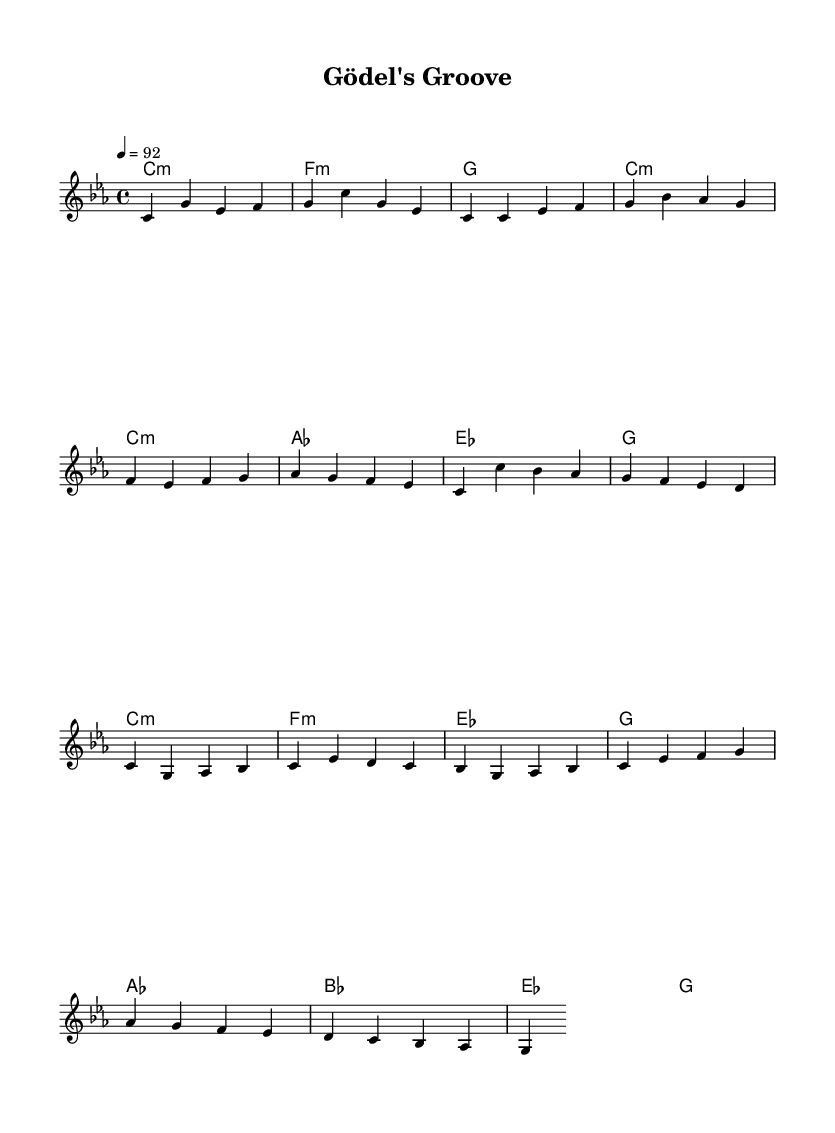What is the key signature of this music? The key signature is C minor, which has three flats (B flat, E flat, and A flat). This can be determined by looking at the key signature section at the beginning of the sheet music where the C minor indication is noted.
Answer: C minor What is the time signature used in the piece? The time signature is 4/4, which indicates four beats per measure. This can be confirmed by looking at the time signature at the beginning of the sheet music; it's indicated in the same section as the key signature.
Answer: 4/4 What is the tempo marking for this piece? The tempo marking is 92 beats per minute. This is indicated in the tempo section of the sheet music where it specifies the tempo as "4 = 92". The number "4" represents a quarter note which is the beat division corresponding to the tempo.
Answer: 92 How many measures are in the verse section? The verse section consists of four measures, as we can count each of the bars in the melody line. The bars can be visually counted from the beginning of the verse until the end according to the melody notation provided.
Answer: 4 What is the first chord in the chorus? The first chord in the chorus is C minor. This can be identified by looking at the chord structure underneath the melody in the chorus section, which indicates "c1:m" as the first chord.
Answer: C minor What is the last chord in the bridge? The last chord in the bridge is G major. To find this, look at the chord changes written in the harmonies section at the end of the bridge. It shows "g" as the final chord in that segment.
Answer: G major How many different sections are in this piece? There are four distinct sections in the piece: Intro, Verse, Chorus, and Bridge. This is determined by observing the structural labeling and the transition from one musical idea to another through the layout in the sheet music.
Answer: 4 